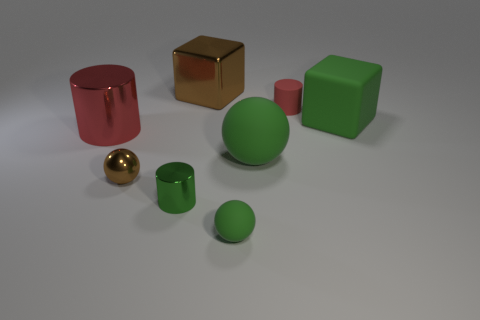Subtract all red rubber spheres. Subtract all small green rubber things. How many objects are left? 7 Add 8 brown balls. How many brown balls are left? 9 Add 3 small cylinders. How many small cylinders exist? 5 Add 1 shiny cubes. How many objects exist? 9 Subtract all brown blocks. How many blocks are left? 1 Subtract all tiny shiny balls. How many balls are left? 2 Subtract 0 cyan spheres. How many objects are left? 8 Subtract all cylinders. How many objects are left? 5 Subtract 1 cylinders. How many cylinders are left? 2 Subtract all purple cylinders. Subtract all blue cubes. How many cylinders are left? 3 